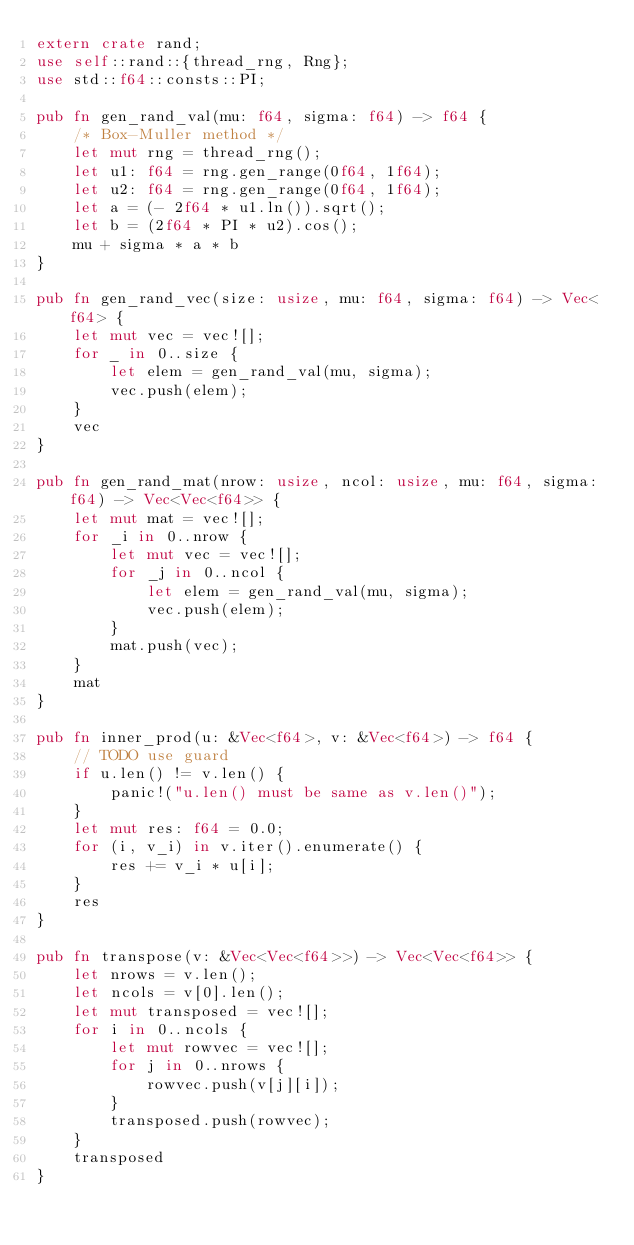Convert code to text. <code><loc_0><loc_0><loc_500><loc_500><_Rust_>extern crate rand;
use self::rand::{thread_rng, Rng};
use std::f64::consts::PI;

pub fn gen_rand_val(mu: f64, sigma: f64) -> f64 {
    /* Box-Muller method */
    let mut rng = thread_rng();
    let u1: f64 = rng.gen_range(0f64, 1f64);
    let u2: f64 = rng.gen_range(0f64, 1f64);
    let a = (- 2f64 * u1.ln()).sqrt();
    let b = (2f64 * PI * u2).cos();
    mu + sigma * a * b
}

pub fn gen_rand_vec(size: usize, mu: f64, sigma: f64) -> Vec<f64> {
    let mut vec = vec![];
    for _ in 0..size {
        let elem = gen_rand_val(mu, sigma);
        vec.push(elem);
    }
    vec
}

pub fn gen_rand_mat(nrow: usize, ncol: usize, mu: f64, sigma: f64) -> Vec<Vec<f64>> {
    let mut mat = vec![];
    for _i in 0..nrow {
        let mut vec = vec![];
        for _j in 0..ncol {
            let elem = gen_rand_val(mu, sigma);
            vec.push(elem);
        }
        mat.push(vec);
    }
    mat
}

pub fn inner_prod(u: &Vec<f64>, v: &Vec<f64>) -> f64 {
    // TODO use guard
    if u.len() != v.len() {
        panic!("u.len() must be same as v.len()");
    }
    let mut res: f64 = 0.0;
    for (i, v_i) in v.iter().enumerate() {
        res += v_i * u[i];
    }
    res
}

pub fn transpose(v: &Vec<Vec<f64>>) -> Vec<Vec<f64>> {
    let nrows = v.len();
    let ncols = v[0].len();
    let mut transposed = vec![];
    for i in 0..ncols {
        let mut rowvec = vec![];
        for j in 0..nrows {
            rowvec.push(v[j][i]);
        }
        transposed.push(rowvec);
    }
    transposed
}
</code> 